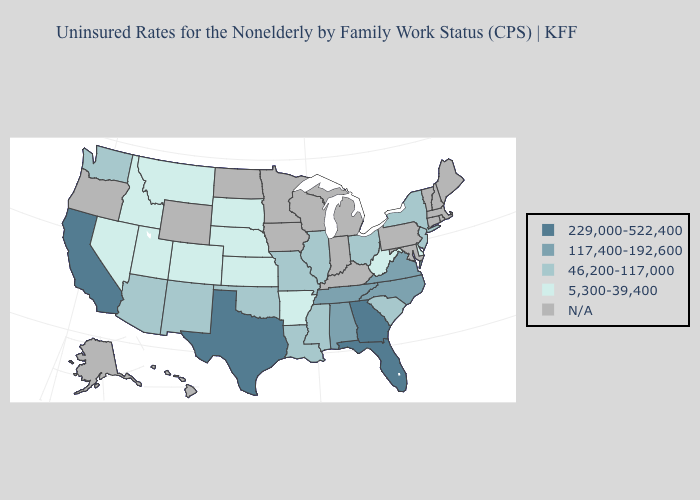Does Georgia have the highest value in the USA?
Quick response, please. Yes. Name the states that have a value in the range 117,400-192,600?
Write a very short answer. Alabama, North Carolina, Tennessee, Virginia. Does Oklahoma have the lowest value in the South?
Write a very short answer. No. What is the value of Michigan?
Keep it brief. N/A. Among the states that border Texas , which have the lowest value?
Answer briefly. Arkansas. What is the value of Alabama?
Write a very short answer. 117,400-192,600. What is the value of North Carolina?
Give a very brief answer. 117,400-192,600. What is the value of Alabama?
Concise answer only. 117,400-192,600. Does Montana have the lowest value in the West?
Answer briefly. Yes. Which states have the lowest value in the USA?
Short answer required. Arkansas, Colorado, Delaware, Idaho, Kansas, Montana, Nebraska, Nevada, South Dakota, Utah, West Virginia. What is the value of Wisconsin?
Answer briefly. N/A. What is the value of Pennsylvania?
Answer briefly. N/A. Does Florida have the highest value in the South?
Be succinct. Yes. What is the lowest value in the South?
Concise answer only. 5,300-39,400. What is the lowest value in the Northeast?
Short answer required. 46,200-117,000. 